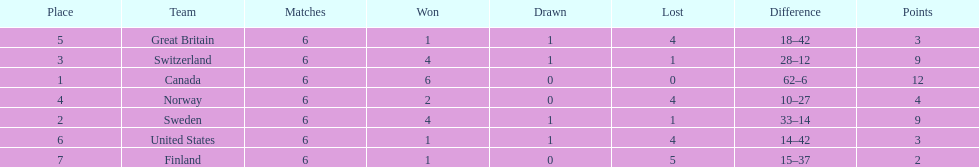How many teams won at least 4 matches? 3. 